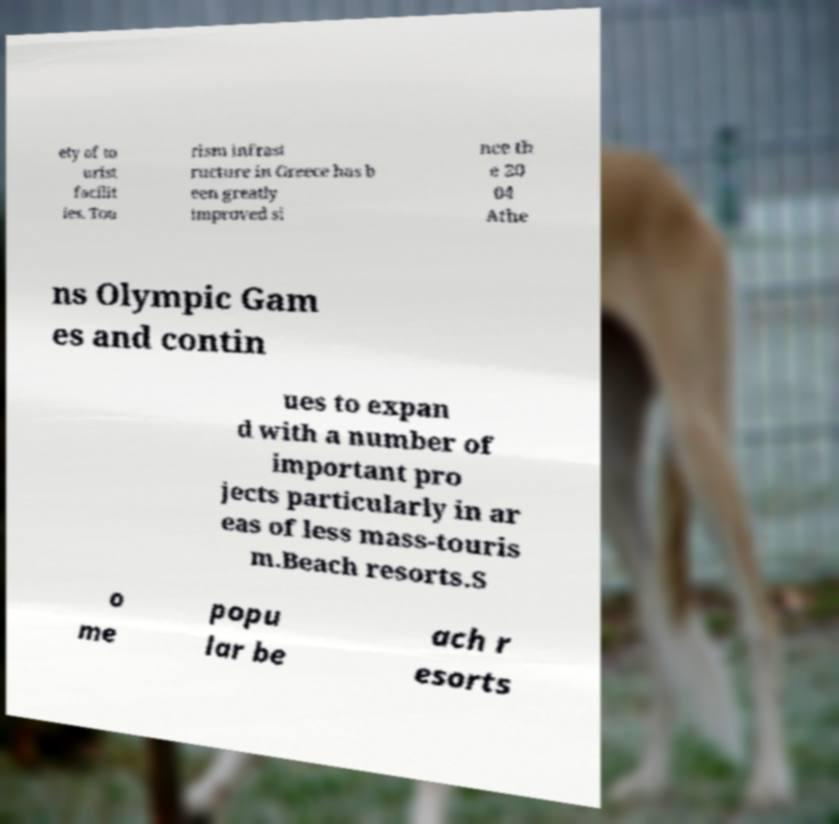I need the written content from this picture converted into text. Can you do that? ety of to urist facilit ies. Tou rism infrast ructure in Greece has b een greatly improved si nce th e 20 04 Athe ns Olympic Gam es and contin ues to expan d with a number of important pro jects particularly in ar eas of less mass-touris m.Beach resorts.S o me popu lar be ach r esorts 